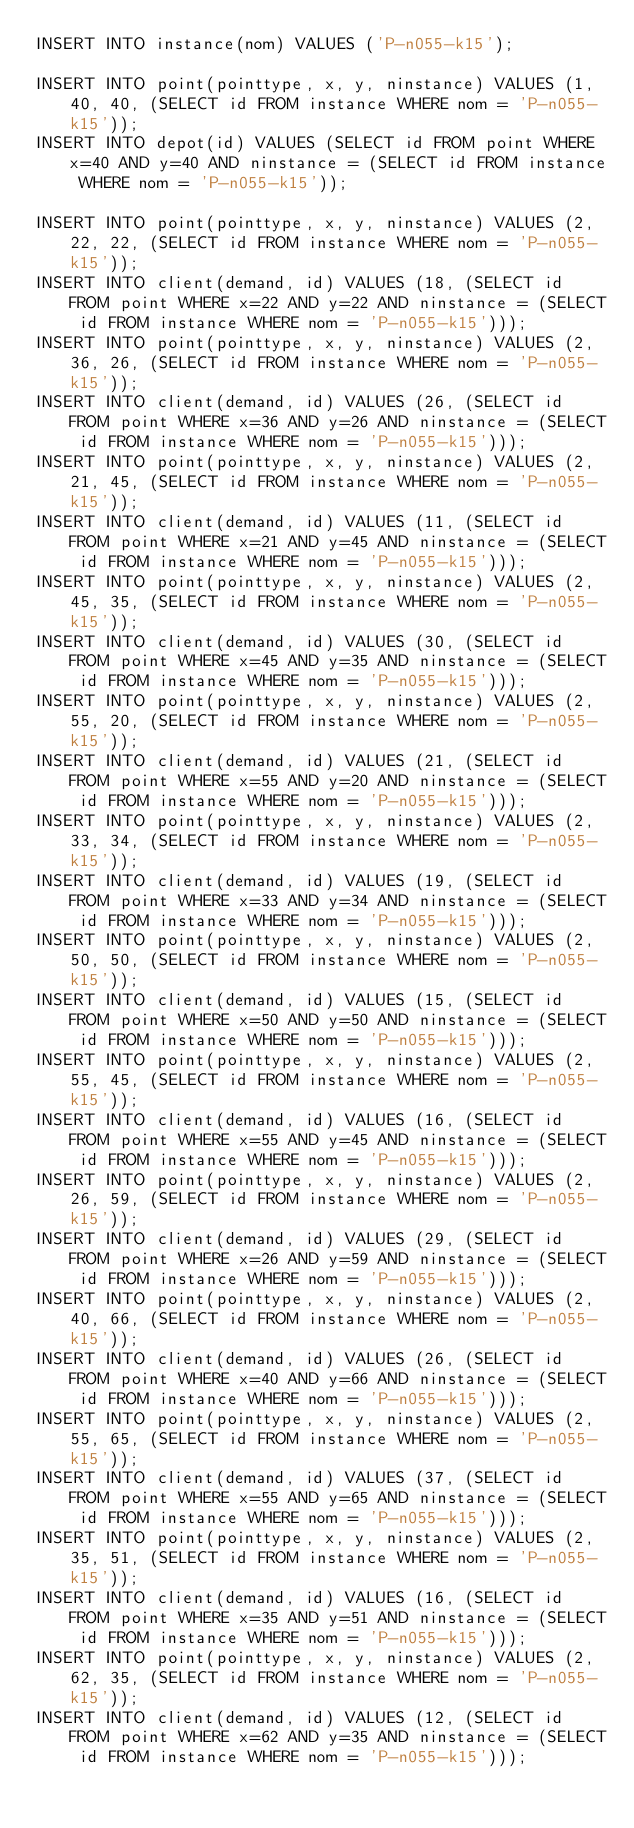Convert code to text. <code><loc_0><loc_0><loc_500><loc_500><_SQL_>INSERT INTO instance(nom) VALUES ('P-n055-k15');

INSERT INTO point(pointtype, x, y, ninstance) VALUES (1, 40, 40, (SELECT id FROM instance WHERE nom = 'P-n055-k15'));
INSERT INTO depot(id) VALUES (SELECT id FROM point WHERE x=40 AND y=40 AND ninstance = (SELECT id FROM instance WHERE nom = 'P-n055-k15'));

INSERT INTO point(pointtype, x, y, ninstance) VALUES (2, 22, 22, (SELECT id FROM instance WHERE nom = 'P-n055-k15'));
INSERT INTO client(demand, id) VALUES (18, (SELECT id FROM point WHERE x=22 AND y=22 AND ninstance = (SELECT id FROM instance WHERE nom = 'P-n055-k15')));
INSERT INTO point(pointtype, x, y, ninstance) VALUES (2, 36, 26, (SELECT id FROM instance WHERE nom = 'P-n055-k15'));
INSERT INTO client(demand, id) VALUES (26, (SELECT id FROM point WHERE x=36 AND y=26 AND ninstance = (SELECT id FROM instance WHERE nom = 'P-n055-k15')));
INSERT INTO point(pointtype, x, y, ninstance) VALUES (2, 21, 45, (SELECT id FROM instance WHERE nom = 'P-n055-k15'));
INSERT INTO client(demand, id) VALUES (11, (SELECT id FROM point WHERE x=21 AND y=45 AND ninstance = (SELECT id FROM instance WHERE nom = 'P-n055-k15')));
INSERT INTO point(pointtype, x, y, ninstance) VALUES (2, 45, 35, (SELECT id FROM instance WHERE nom = 'P-n055-k15'));
INSERT INTO client(demand, id) VALUES (30, (SELECT id FROM point WHERE x=45 AND y=35 AND ninstance = (SELECT id FROM instance WHERE nom = 'P-n055-k15')));
INSERT INTO point(pointtype, x, y, ninstance) VALUES (2, 55, 20, (SELECT id FROM instance WHERE nom = 'P-n055-k15'));
INSERT INTO client(demand, id) VALUES (21, (SELECT id FROM point WHERE x=55 AND y=20 AND ninstance = (SELECT id FROM instance WHERE nom = 'P-n055-k15')));
INSERT INTO point(pointtype, x, y, ninstance) VALUES (2, 33, 34, (SELECT id FROM instance WHERE nom = 'P-n055-k15'));
INSERT INTO client(demand, id) VALUES (19, (SELECT id FROM point WHERE x=33 AND y=34 AND ninstance = (SELECT id FROM instance WHERE nom = 'P-n055-k15')));
INSERT INTO point(pointtype, x, y, ninstance) VALUES (2, 50, 50, (SELECT id FROM instance WHERE nom = 'P-n055-k15'));
INSERT INTO client(demand, id) VALUES (15, (SELECT id FROM point WHERE x=50 AND y=50 AND ninstance = (SELECT id FROM instance WHERE nom = 'P-n055-k15')));
INSERT INTO point(pointtype, x, y, ninstance) VALUES (2, 55, 45, (SELECT id FROM instance WHERE nom = 'P-n055-k15'));
INSERT INTO client(demand, id) VALUES (16, (SELECT id FROM point WHERE x=55 AND y=45 AND ninstance = (SELECT id FROM instance WHERE nom = 'P-n055-k15')));
INSERT INTO point(pointtype, x, y, ninstance) VALUES (2, 26, 59, (SELECT id FROM instance WHERE nom = 'P-n055-k15'));
INSERT INTO client(demand, id) VALUES (29, (SELECT id FROM point WHERE x=26 AND y=59 AND ninstance = (SELECT id FROM instance WHERE nom = 'P-n055-k15')));
INSERT INTO point(pointtype, x, y, ninstance) VALUES (2, 40, 66, (SELECT id FROM instance WHERE nom = 'P-n055-k15'));
INSERT INTO client(demand, id) VALUES (26, (SELECT id FROM point WHERE x=40 AND y=66 AND ninstance = (SELECT id FROM instance WHERE nom = 'P-n055-k15')));
INSERT INTO point(pointtype, x, y, ninstance) VALUES (2, 55, 65, (SELECT id FROM instance WHERE nom = 'P-n055-k15'));
INSERT INTO client(demand, id) VALUES (37, (SELECT id FROM point WHERE x=55 AND y=65 AND ninstance = (SELECT id FROM instance WHERE nom = 'P-n055-k15')));
INSERT INTO point(pointtype, x, y, ninstance) VALUES (2, 35, 51, (SELECT id FROM instance WHERE nom = 'P-n055-k15'));
INSERT INTO client(demand, id) VALUES (16, (SELECT id FROM point WHERE x=35 AND y=51 AND ninstance = (SELECT id FROM instance WHERE nom = 'P-n055-k15')));
INSERT INTO point(pointtype, x, y, ninstance) VALUES (2, 62, 35, (SELECT id FROM instance WHERE nom = 'P-n055-k15'));
INSERT INTO client(demand, id) VALUES (12, (SELECT id FROM point WHERE x=62 AND y=35 AND ninstance = (SELECT id FROM instance WHERE nom = 'P-n055-k15')));</code> 